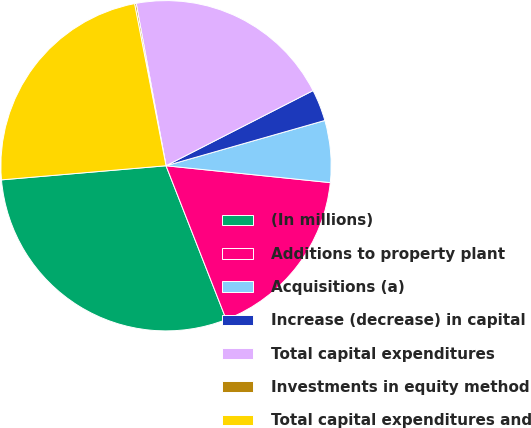<chart> <loc_0><loc_0><loc_500><loc_500><pie_chart><fcel>(In millions)<fcel>Additions to property plant<fcel>Acquisitions (a)<fcel>Increase (decrease) in capital<fcel>Total capital expenditures<fcel>Investments in equity method<fcel>Total capital expenditures and<nl><fcel>29.58%<fcel>17.43%<fcel>6.05%<fcel>3.1%<fcel>20.37%<fcel>0.16%<fcel>23.31%<nl></chart> 